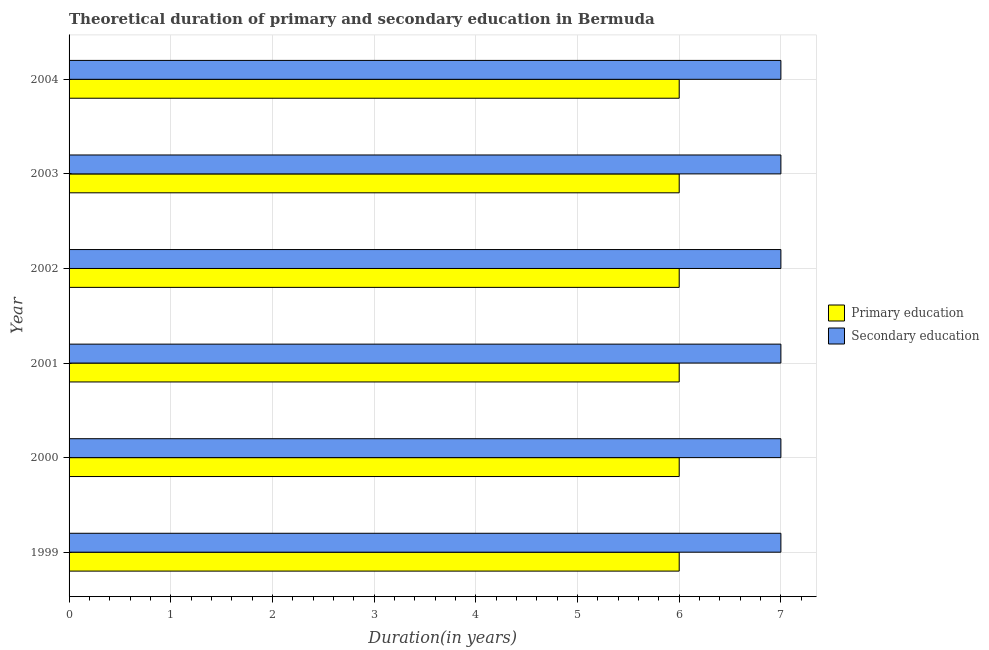How many groups of bars are there?
Provide a succinct answer. 6. Are the number of bars per tick equal to the number of legend labels?
Provide a short and direct response. Yes. Are the number of bars on each tick of the Y-axis equal?
Keep it short and to the point. Yes. How many bars are there on the 6th tick from the top?
Give a very brief answer. 2. How many bars are there on the 4th tick from the bottom?
Provide a short and direct response. 2. What is the label of the 1st group of bars from the top?
Offer a terse response. 2004. What is the duration of secondary education in 1999?
Give a very brief answer. 7. Across all years, what is the maximum duration of primary education?
Your answer should be very brief. 6. Across all years, what is the minimum duration of secondary education?
Your response must be concise. 7. In which year was the duration of primary education maximum?
Give a very brief answer. 1999. In which year was the duration of secondary education minimum?
Your answer should be compact. 1999. What is the total duration of secondary education in the graph?
Offer a terse response. 42. What is the difference between the duration of primary education in 2003 and the duration of secondary education in 1999?
Ensure brevity in your answer.  -1. What is the average duration of secondary education per year?
Your answer should be very brief. 7. In the year 2003, what is the difference between the duration of primary education and duration of secondary education?
Provide a succinct answer. -1. In how many years, is the duration of primary education greater than 2.8 years?
Offer a terse response. 6. Is the duration of primary education in 2001 less than that in 2002?
Offer a terse response. No. What is the difference between the highest and the lowest duration of primary education?
Make the answer very short. 0. In how many years, is the duration of primary education greater than the average duration of primary education taken over all years?
Give a very brief answer. 0. What does the 1st bar from the top in 2003 represents?
Your response must be concise. Secondary education. What does the 2nd bar from the bottom in 2004 represents?
Give a very brief answer. Secondary education. Are all the bars in the graph horizontal?
Ensure brevity in your answer.  Yes. What is the difference between two consecutive major ticks on the X-axis?
Offer a terse response. 1. Are the values on the major ticks of X-axis written in scientific E-notation?
Offer a terse response. No. Does the graph contain any zero values?
Ensure brevity in your answer.  No. Does the graph contain grids?
Provide a succinct answer. Yes. Where does the legend appear in the graph?
Offer a very short reply. Center right. How many legend labels are there?
Your answer should be very brief. 2. How are the legend labels stacked?
Keep it short and to the point. Vertical. What is the title of the graph?
Give a very brief answer. Theoretical duration of primary and secondary education in Bermuda. What is the label or title of the X-axis?
Offer a terse response. Duration(in years). What is the Duration(in years) in Primary education in 2001?
Provide a succinct answer. 6. What is the Duration(in years) in Secondary education in 2002?
Ensure brevity in your answer.  7. What is the Duration(in years) in Primary education in 2003?
Your response must be concise. 6. What is the Duration(in years) in Primary education in 2004?
Make the answer very short. 6. What is the Duration(in years) of Secondary education in 2004?
Your answer should be very brief. 7. Across all years, what is the minimum Duration(in years) of Primary education?
Give a very brief answer. 6. Across all years, what is the minimum Duration(in years) of Secondary education?
Provide a short and direct response. 7. What is the difference between the Duration(in years) in Primary education in 1999 and that in 2000?
Offer a very short reply. 0. What is the difference between the Duration(in years) of Primary education in 1999 and that in 2001?
Ensure brevity in your answer.  0. What is the difference between the Duration(in years) of Secondary education in 1999 and that in 2002?
Make the answer very short. 0. What is the difference between the Duration(in years) in Secondary education in 1999 and that in 2004?
Give a very brief answer. 0. What is the difference between the Duration(in years) of Secondary education in 2000 and that in 2001?
Provide a short and direct response. 0. What is the difference between the Duration(in years) of Primary education in 2000 and that in 2002?
Provide a short and direct response. 0. What is the difference between the Duration(in years) of Primary education in 2000 and that in 2003?
Offer a very short reply. 0. What is the difference between the Duration(in years) of Secondary education in 2000 and that in 2003?
Your response must be concise. 0. What is the difference between the Duration(in years) of Primary education in 2000 and that in 2004?
Give a very brief answer. 0. What is the difference between the Duration(in years) in Secondary education in 2000 and that in 2004?
Your answer should be compact. 0. What is the difference between the Duration(in years) of Primary education in 2001 and that in 2002?
Offer a terse response. 0. What is the difference between the Duration(in years) of Secondary education in 2001 and that in 2002?
Make the answer very short. 0. What is the difference between the Duration(in years) of Primary education in 2001 and that in 2004?
Provide a succinct answer. 0. What is the difference between the Duration(in years) in Secondary education in 2001 and that in 2004?
Give a very brief answer. 0. What is the difference between the Duration(in years) of Primary education in 2002 and that in 2003?
Ensure brevity in your answer.  0. What is the difference between the Duration(in years) of Primary education in 2002 and that in 2004?
Your answer should be compact. 0. What is the difference between the Duration(in years) in Secondary education in 2002 and that in 2004?
Offer a terse response. 0. What is the difference between the Duration(in years) of Primary education in 2003 and that in 2004?
Keep it short and to the point. 0. What is the difference between the Duration(in years) of Secondary education in 2003 and that in 2004?
Provide a succinct answer. 0. What is the difference between the Duration(in years) in Primary education in 1999 and the Duration(in years) in Secondary education in 2000?
Your answer should be very brief. -1. What is the difference between the Duration(in years) of Primary education in 1999 and the Duration(in years) of Secondary education in 2001?
Keep it short and to the point. -1. What is the difference between the Duration(in years) of Primary education in 1999 and the Duration(in years) of Secondary education in 2004?
Provide a succinct answer. -1. What is the difference between the Duration(in years) of Primary education in 2000 and the Duration(in years) of Secondary education in 2001?
Give a very brief answer. -1. What is the difference between the Duration(in years) of Primary education in 2000 and the Duration(in years) of Secondary education in 2002?
Your answer should be very brief. -1. What is the difference between the Duration(in years) in Primary education in 2000 and the Duration(in years) in Secondary education in 2003?
Make the answer very short. -1. What is the difference between the Duration(in years) in Primary education in 2000 and the Duration(in years) in Secondary education in 2004?
Your answer should be compact. -1. What is the difference between the Duration(in years) in Primary education in 2001 and the Duration(in years) in Secondary education in 2004?
Make the answer very short. -1. What is the difference between the Duration(in years) in Primary education in 2002 and the Duration(in years) in Secondary education in 2003?
Your answer should be compact. -1. What is the difference between the Duration(in years) of Primary education in 2002 and the Duration(in years) of Secondary education in 2004?
Offer a very short reply. -1. What is the average Duration(in years) of Primary education per year?
Provide a short and direct response. 6. In the year 1999, what is the difference between the Duration(in years) of Primary education and Duration(in years) of Secondary education?
Make the answer very short. -1. In the year 2000, what is the difference between the Duration(in years) in Primary education and Duration(in years) in Secondary education?
Provide a succinct answer. -1. In the year 2003, what is the difference between the Duration(in years) of Primary education and Duration(in years) of Secondary education?
Your response must be concise. -1. What is the ratio of the Duration(in years) in Primary education in 1999 to that in 2000?
Provide a succinct answer. 1. What is the ratio of the Duration(in years) in Secondary education in 1999 to that in 2000?
Your response must be concise. 1. What is the ratio of the Duration(in years) of Primary education in 1999 to that in 2001?
Your response must be concise. 1. What is the ratio of the Duration(in years) of Secondary education in 1999 to that in 2001?
Give a very brief answer. 1. What is the ratio of the Duration(in years) of Primary education in 1999 to that in 2002?
Provide a short and direct response. 1. What is the ratio of the Duration(in years) of Secondary education in 1999 to that in 2002?
Give a very brief answer. 1. What is the ratio of the Duration(in years) in Primary education in 1999 to that in 2004?
Offer a terse response. 1. What is the ratio of the Duration(in years) in Primary education in 2000 to that in 2001?
Provide a succinct answer. 1. What is the ratio of the Duration(in years) of Secondary education in 2000 to that in 2001?
Your answer should be very brief. 1. What is the ratio of the Duration(in years) in Secondary education in 2000 to that in 2002?
Provide a short and direct response. 1. What is the ratio of the Duration(in years) of Secondary education in 2000 to that in 2003?
Make the answer very short. 1. What is the ratio of the Duration(in years) of Primary education in 2001 to that in 2002?
Provide a short and direct response. 1. What is the ratio of the Duration(in years) of Primary education in 2001 to that in 2003?
Provide a succinct answer. 1. What is the ratio of the Duration(in years) of Primary education in 2001 to that in 2004?
Your answer should be very brief. 1. What is the ratio of the Duration(in years) of Secondary education in 2001 to that in 2004?
Provide a short and direct response. 1. What is the ratio of the Duration(in years) in Primary education in 2002 to that in 2003?
Provide a succinct answer. 1. What is the ratio of the Duration(in years) of Primary education in 2002 to that in 2004?
Offer a very short reply. 1. What is the ratio of the Duration(in years) of Secondary education in 2002 to that in 2004?
Your response must be concise. 1. What is the ratio of the Duration(in years) in Secondary education in 2003 to that in 2004?
Keep it short and to the point. 1. What is the difference between the highest and the second highest Duration(in years) in Secondary education?
Offer a terse response. 0. 